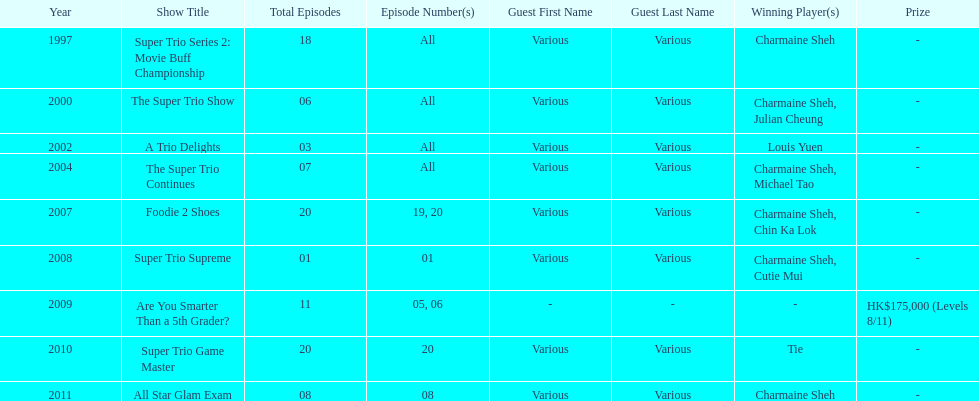Parse the full table. {'header': ['Year', 'Show Title', 'Total Episodes', 'Episode Number(s)', 'Guest First Name', 'Guest Last Name', 'Winning Player(s)', 'Prize'], 'rows': [['1997', 'Super Trio Series 2: Movie Buff Championship', '18', 'All', 'Various', 'Various', 'Charmaine Sheh', '-'], ['2000', 'The Super Trio Show', '06', 'All', 'Various', 'Various', 'Charmaine Sheh, Julian Cheung', '-'], ['2002', 'A Trio Delights', '03', 'All', 'Various', 'Various', 'Louis Yuen', '-'], ['2004', 'The Super Trio Continues', '07', 'All', 'Various', 'Various', 'Charmaine Sheh, Michael Tao', '-'], ['2007', 'Foodie 2 Shoes', '20', '19, 20', 'Various', 'Various', 'Charmaine Sheh, Chin Ka Lok', '-'], ['2008', 'Super Trio Supreme', '01', '01', 'Various', 'Various', 'Charmaine Sheh, Cutie Mui', '-'], ['2009', 'Are You Smarter Than a 5th Grader?', '11', '05, 06', '-', '-', '-', 'HK$175,000 (Levels 8/11)'], ['2010', 'Super Trio Game Master', '20', '20', 'Various', 'Various', 'Tie', '-'], ['2011', 'All Star Glam Exam', '08', '08', 'Various', 'Various', 'Charmaine Sheh', '-']]} How many times has charmaine sheh won on a variety show? 6. 